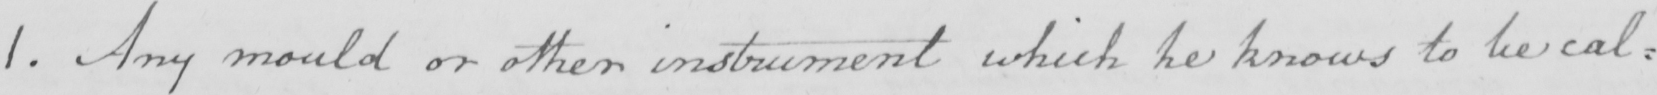Please transcribe the handwritten text in this image. 1 . Any mould or other instrument which he knows to be cal= 